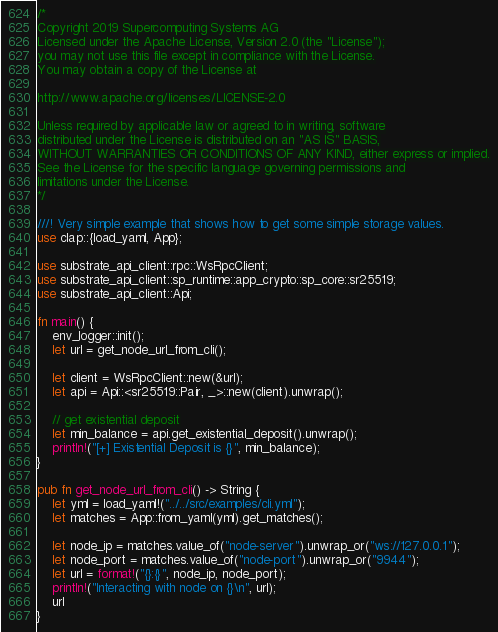Convert code to text. <code><loc_0><loc_0><loc_500><loc_500><_Rust_>/*
Copyright 2019 Supercomputing Systems AG
Licensed under the Apache License, Version 2.0 (the "License");
you may not use this file except in compliance with the License.
You may obtain a copy of the License at

http://www.apache.org/licenses/LICENSE-2.0

Unless required by applicable law or agreed to in writing, software
distributed under the License is distributed on an "AS IS" BASIS,
WITHOUT WARRANTIES OR CONDITIONS OF ANY KIND, either express or implied.
See the License for the specific language governing permissions and
limitations under the License.
*/

///! Very simple example that shows how to get some simple storage values.
use clap::{load_yaml, App};

use substrate_api_client::rpc::WsRpcClient;
use substrate_api_client::sp_runtime::app_crypto::sp_core::sr25519;
use substrate_api_client::Api;

fn main() {
    env_logger::init();
    let url = get_node_url_from_cli();

    let client = WsRpcClient::new(&url);
    let api = Api::<sr25519::Pair, _>::new(client).unwrap();

    // get existential deposit
    let min_balance = api.get_existential_deposit().unwrap();
    println!("[+] Existential Deposit is {}", min_balance);
}

pub fn get_node_url_from_cli() -> String {
    let yml = load_yaml!("../../src/examples/cli.yml");
    let matches = App::from_yaml(yml).get_matches();

    let node_ip = matches.value_of("node-server").unwrap_or("ws://127.0.0.1");
    let node_port = matches.value_of("node-port").unwrap_or("9944");
    let url = format!("{}:{}", node_ip, node_port);
    println!("Interacting with node on {}\n", url);
    url
}
</code> 